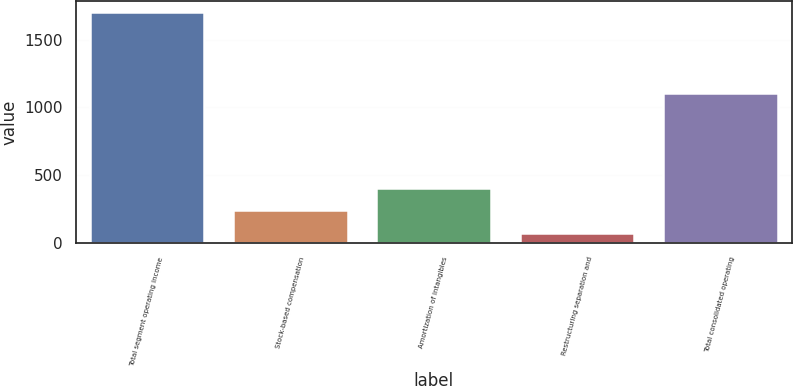Convert chart to OTSL. <chart><loc_0><loc_0><loc_500><loc_500><bar_chart><fcel>Total segment operating income<fcel>Stock-based compensation<fcel>Amortization of intangibles<fcel>Restructuring separation and<fcel>Total consolidated operating<nl><fcel>1702<fcel>239.5<fcel>402<fcel>77<fcel>1106<nl></chart> 